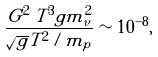Convert formula to latex. <formula><loc_0><loc_0><loc_500><loc_500>\frac { G ^ { 2 } \, T ^ { 3 } g m ^ { 2 } _ { \nu } } { \sqrt { g } T ^ { 2 } / m _ { p } } \sim 1 0 ^ { - 8 } ,</formula> 